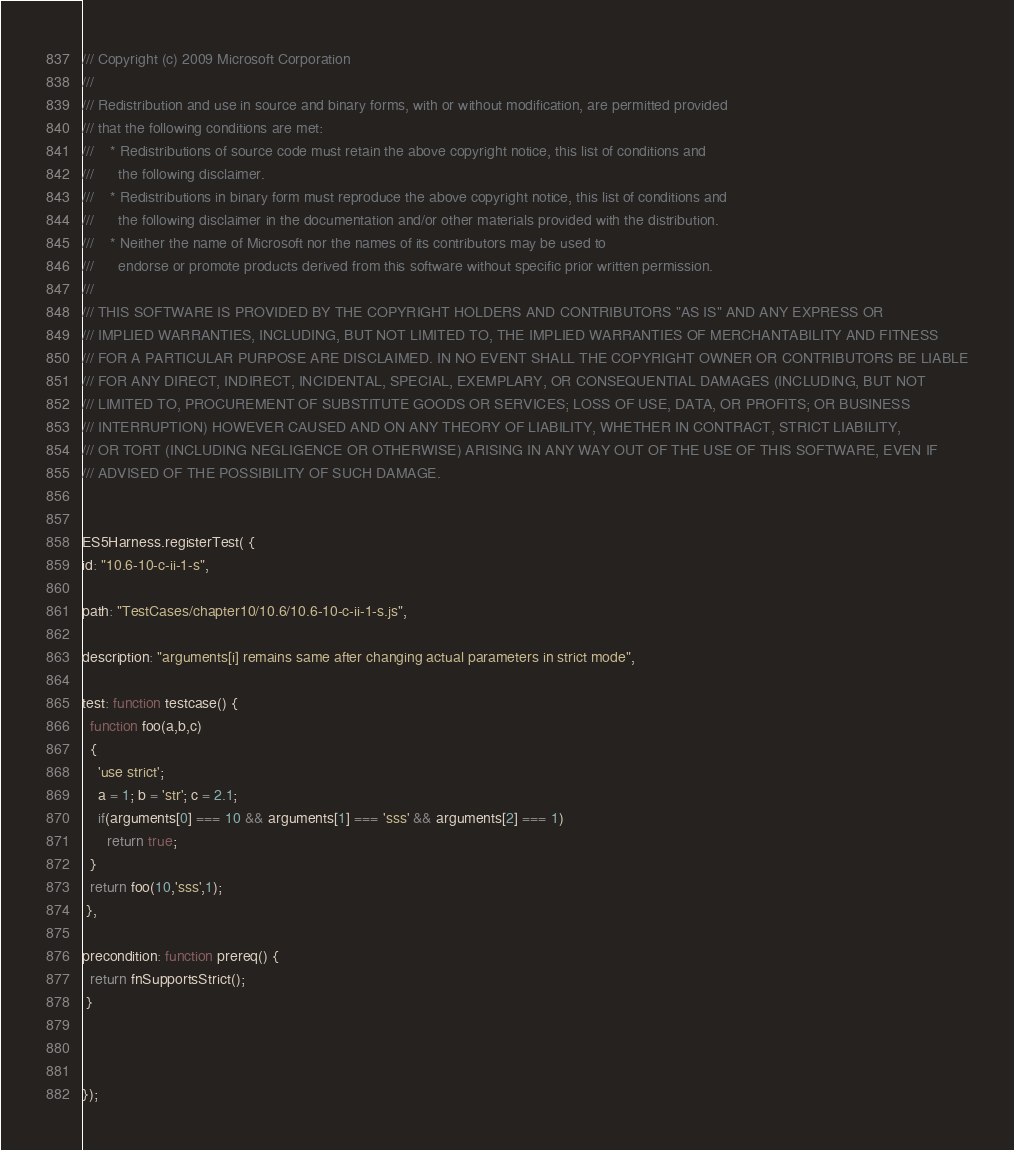<code> <loc_0><loc_0><loc_500><loc_500><_JavaScript_>/// Copyright (c) 2009 Microsoft Corporation 
/// 
/// Redistribution and use in source and binary forms, with or without modification, are permitted provided
/// that the following conditions are met: 
///    * Redistributions of source code must retain the above copyright notice, this list of conditions and
///      the following disclaimer. 
///    * Redistributions in binary form must reproduce the above copyright notice, this list of conditions and 
///      the following disclaimer in the documentation and/or other materials provided with the distribution.  
///    * Neither the name of Microsoft nor the names of its contributors may be used to
///      endorse or promote products derived from this software without specific prior written permission.
/// 
/// THIS SOFTWARE IS PROVIDED BY THE COPYRIGHT HOLDERS AND CONTRIBUTORS "AS IS" AND ANY EXPRESS OR
/// IMPLIED WARRANTIES, INCLUDING, BUT NOT LIMITED TO, THE IMPLIED WARRANTIES OF MERCHANTABILITY AND FITNESS
/// FOR A PARTICULAR PURPOSE ARE DISCLAIMED. IN NO EVENT SHALL THE COPYRIGHT OWNER OR CONTRIBUTORS BE LIABLE
/// FOR ANY DIRECT, INDIRECT, INCIDENTAL, SPECIAL, EXEMPLARY, OR CONSEQUENTIAL DAMAGES (INCLUDING, BUT NOT
/// LIMITED TO, PROCUREMENT OF SUBSTITUTE GOODS OR SERVICES; LOSS OF USE, DATA, OR PROFITS; OR BUSINESS
/// INTERRUPTION) HOWEVER CAUSED AND ON ANY THEORY OF LIABILITY, WHETHER IN CONTRACT, STRICT LIABILITY,
/// OR TORT (INCLUDING NEGLIGENCE OR OTHERWISE) ARISING IN ANY WAY OUT OF THE USE OF THIS SOFTWARE, EVEN IF
/// ADVISED OF THE POSSIBILITY OF SUCH DAMAGE. 


ES5Harness.registerTest( {
id: "10.6-10-c-ii-1-s",

path: "TestCases/chapter10/10.6/10.6-10-c-ii-1-s.js",

description: "arguments[i] remains same after changing actual parameters in strict mode",

test: function testcase() {
  function foo(a,b,c)
  {
    'use strict';
    a = 1; b = 'str'; c = 2.1;
    if(arguments[0] === 10 && arguments[1] === 'sss' && arguments[2] === 1)
      return true;   
  }
  return foo(10,'sss',1);
 },

precondition: function prereq() {
  return fnSupportsStrict();
 }



});
</code> 